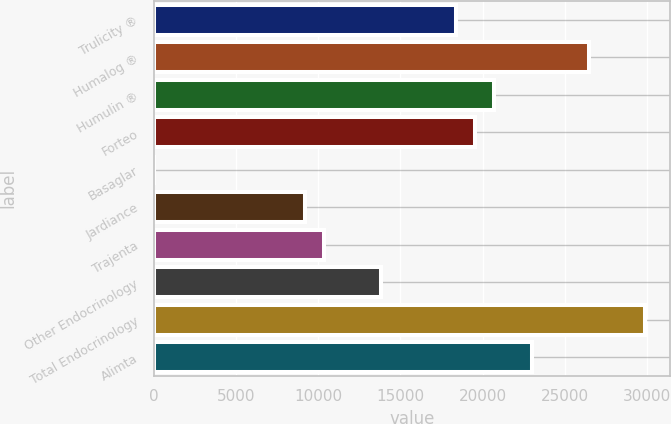Convert chart to OTSL. <chart><loc_0><loc_0><loc_500><loc_500><bar_chart><fcel>Trulicity ®<fcel>Humalog ®<fcel>Humulin ®<fcel>Forteo<fcel>Basaglar<fcel>Jardiance<fcel>Trajenta<fcel>Other Endocrinology<fcel>Total Endocrinology<fcel>Alimta<nl><fcel>18400.4<fcel>26443.7<fcel>20698.5<fcel>19549.5<fcel>15.8<fcel>9208.12<fcel>10357.2<fcel>13804.3<fcel>29890.8<fcel>22996.6<nl></chart> 